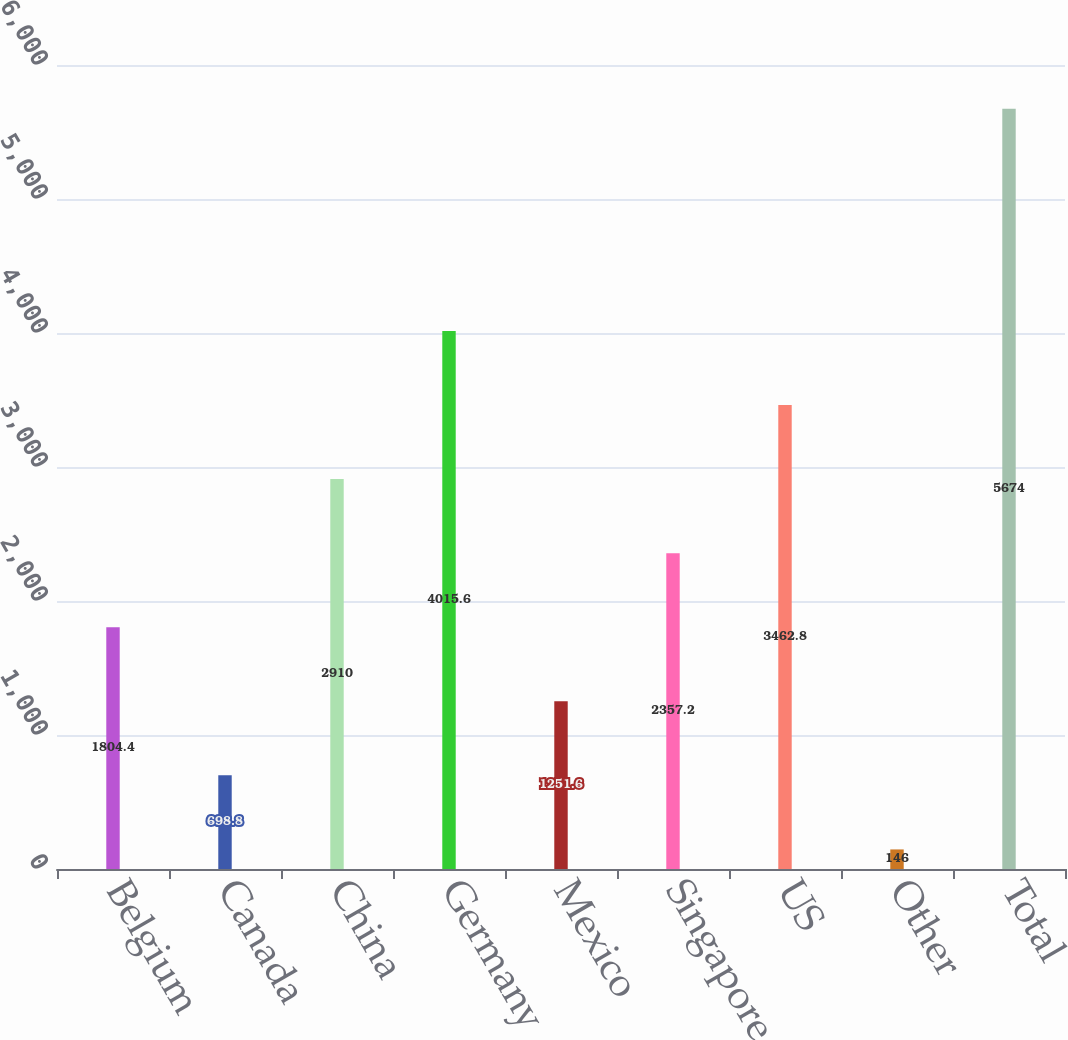Convert chart to OTSL. <chart><loc_0><loc_0><loc_500><loc_500><bar_chart><fcel>Belgium<fcel>Canada<fcel>China<fcel>Germany<fcel>Mexico<fcel>Singapore<fcel>US<fcel>Other<fcel>Total<nl><fcel>1804.4<fcel>698.8<fcel>2910<fcel>4015.6<fcel>1251.6<fcel>2357.2<fcel>3462.8<fcel>146<fcel>5674<nl></chart> 